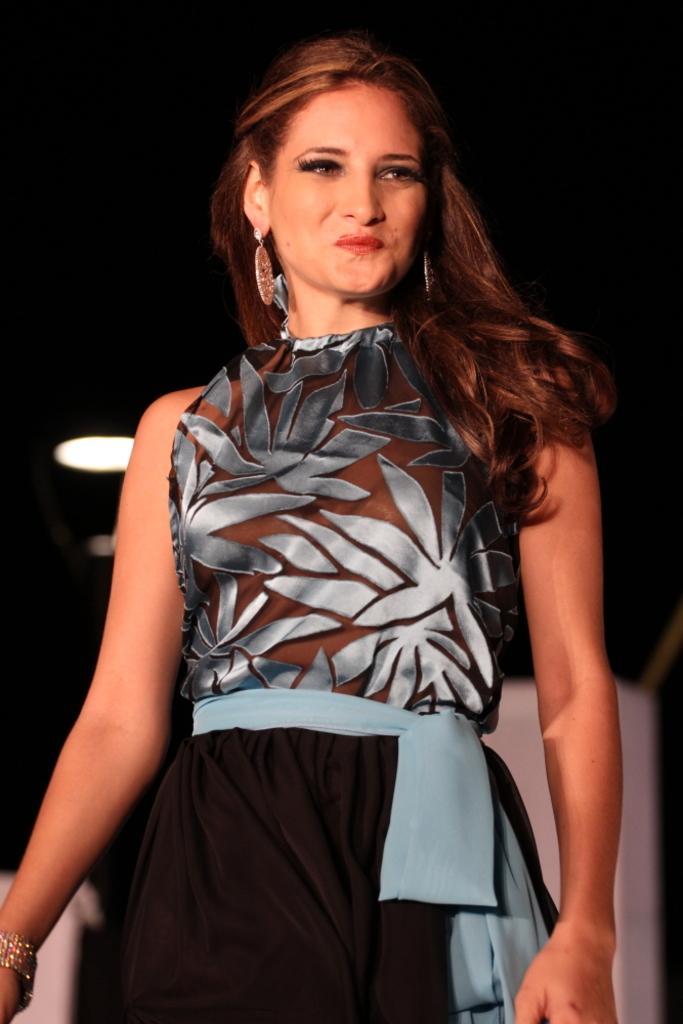Describe this image in one or two sentences. In this image we can see a woman. She is wearing black and blue color dress with some jewelry. 